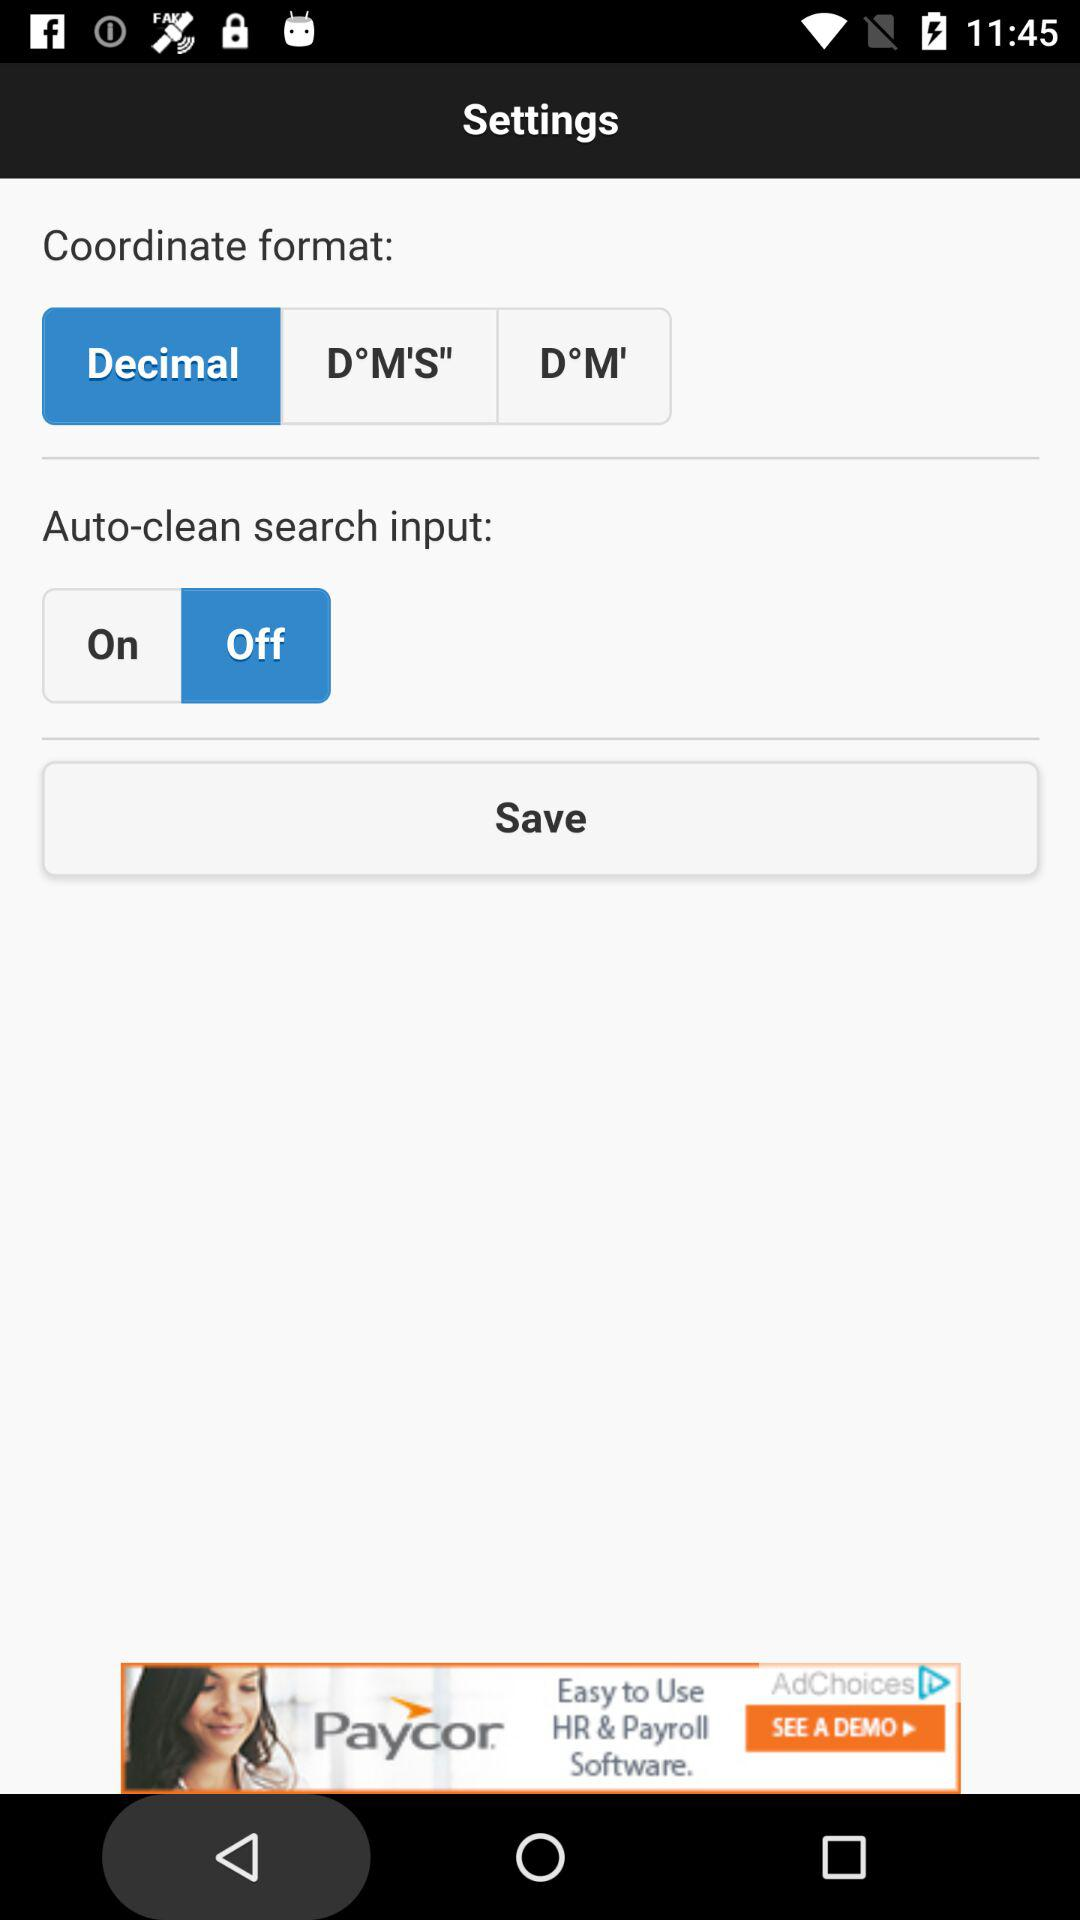What is the status of "Auto-clean search input"? The status is "off". 